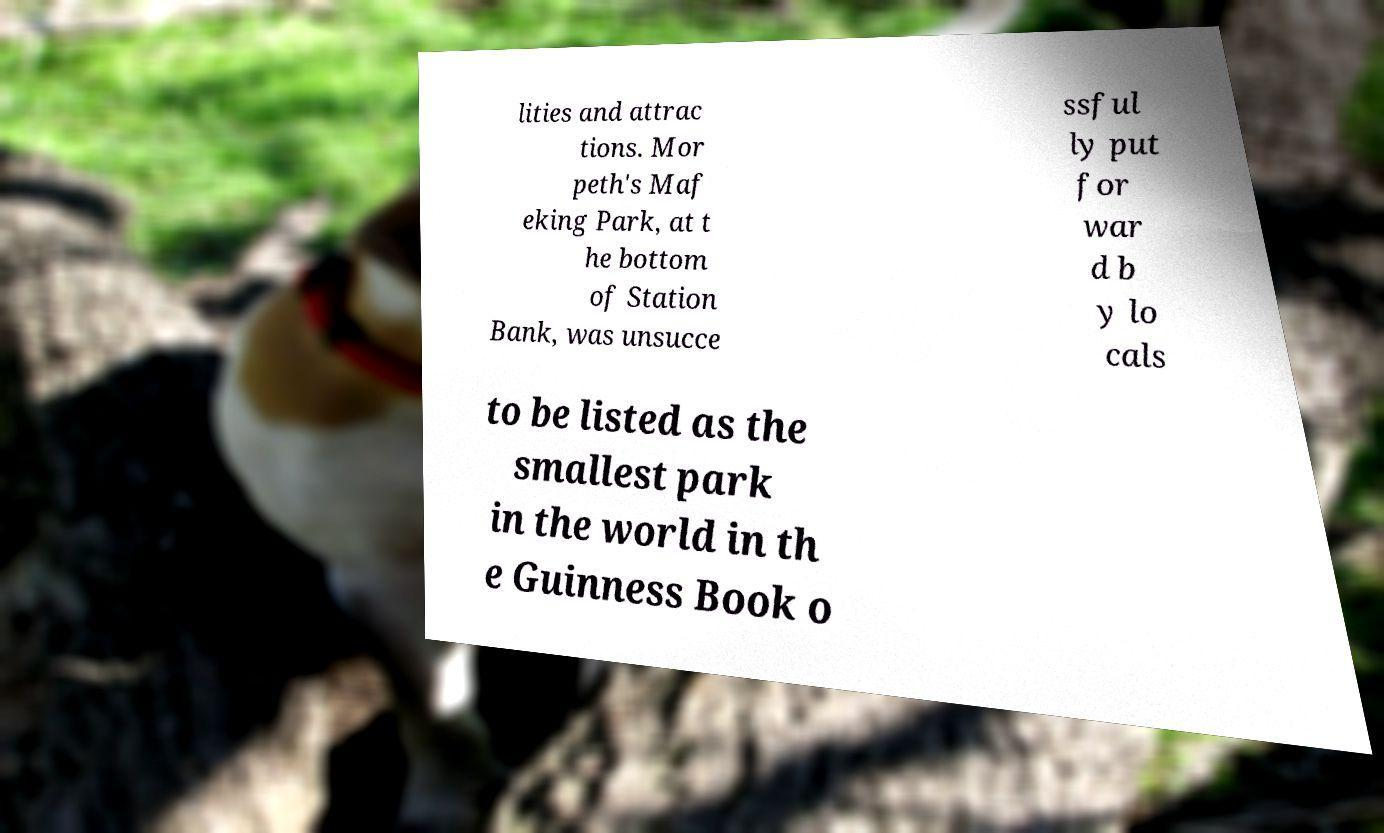There's text embedded in this image that I need extracted. Can you transcribe it verbatim? lities and attrac tions. Mor peth's Maf eking Park, at t he bottom of Station Bank, was unsucce ssful ly put for war d b y lo cals to be listed as the smallest park in the world in th e Guinness Book o 